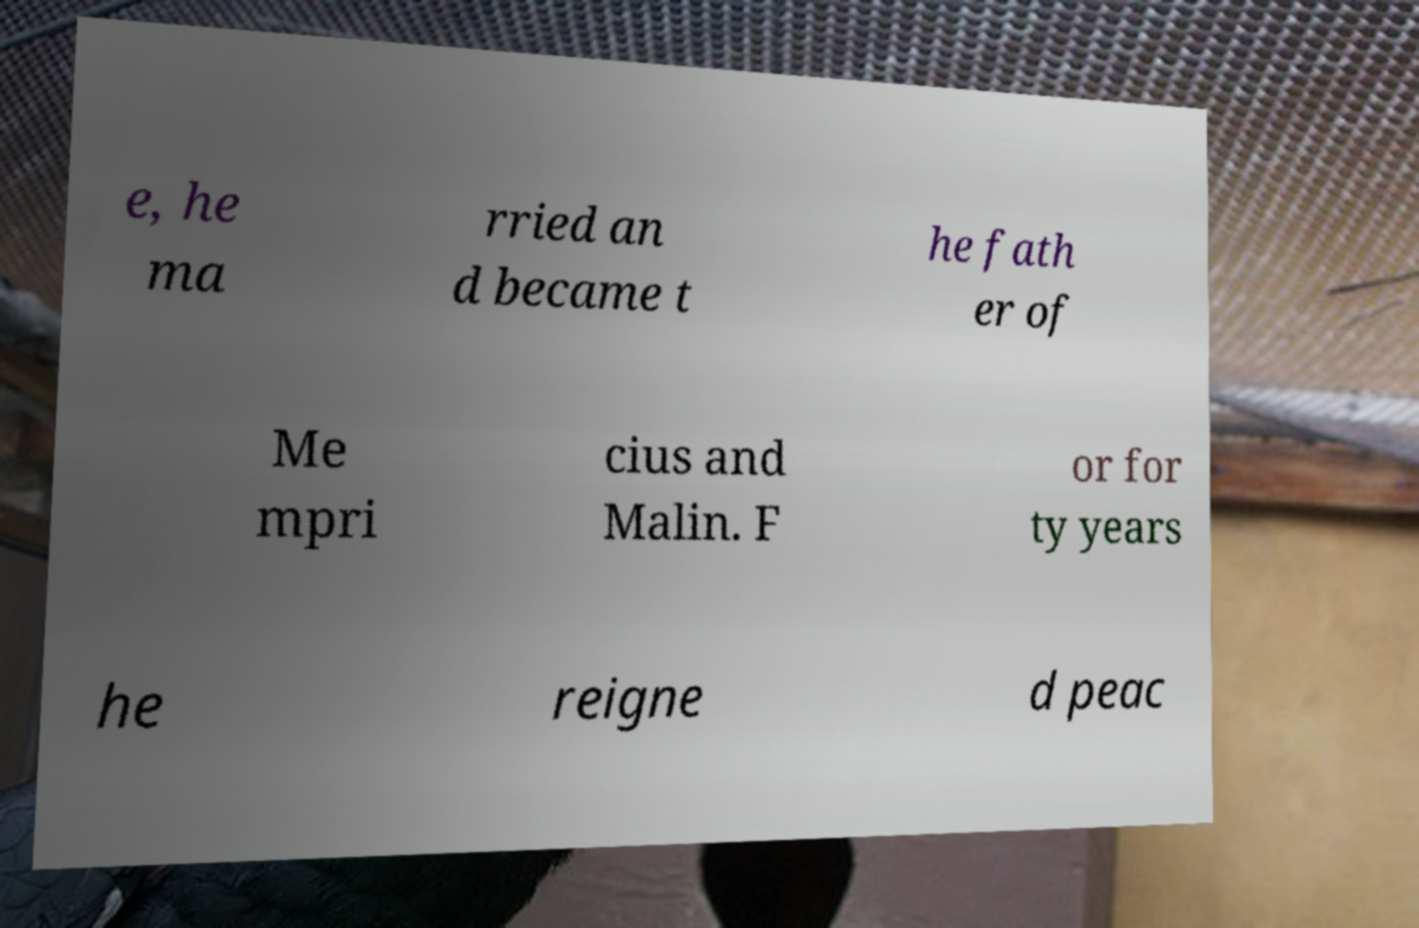Please read and relay the text visible in this image. What does it say? e, he ma rried an d became t he fath er of Me mpri cius and Malin. F or for ty years he reigne d peac 